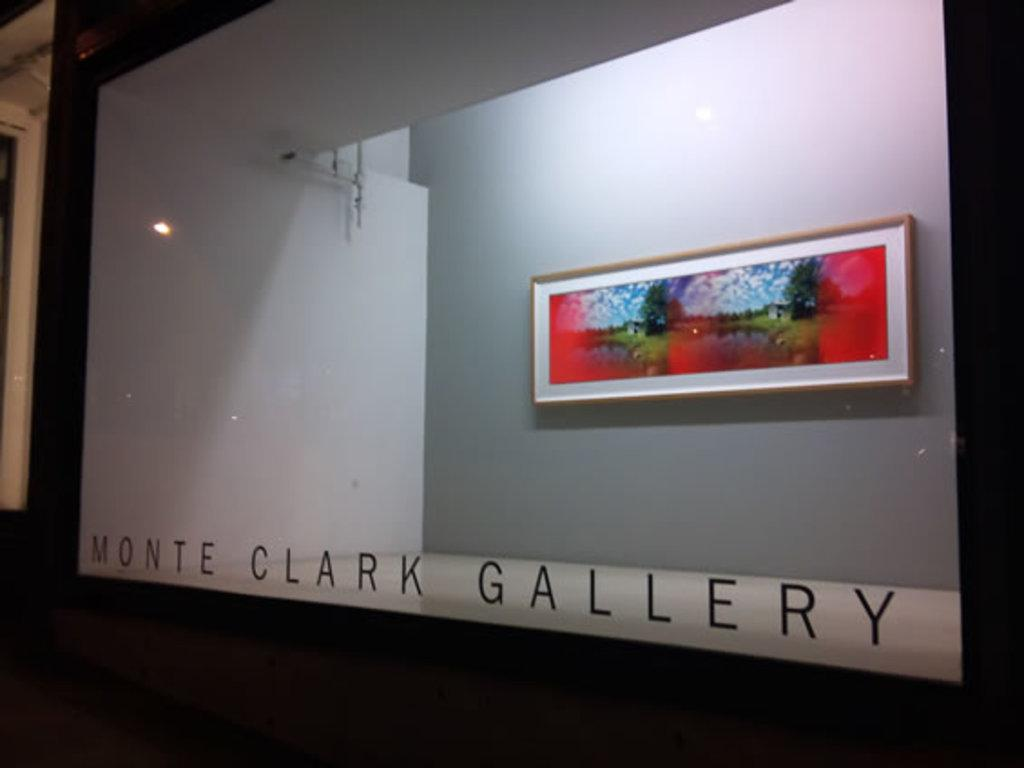<image>
Relay a brief, clear account of the picture shown. A rectagular piece of artwork on display behind a glass window with Monte Clark Gallery on the window. 